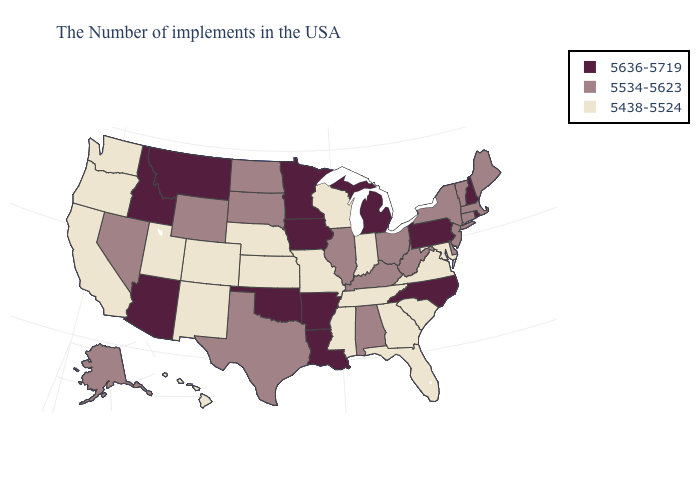What is the highest value in the West ?
Be succinct. 5636-5719. What is the value of Iowa?
Write a very short answer. 5636-5719. Name the states that have a value in the range 5636-5719?
Quick response, please. Rhode Island, New Hampshire, Pennsylvania, North Carolina, Michigan, Louisiana, Arkansas, Minnesota, Iowa, Oklahoma, Montana, Arizona, Idaho. Does Iowa have the highest value in the USA?
Write a very short answer. Yes. Does Colorado have the highest value in the West?
Keep it brief. No. Name the states that have a value in the range 5534-5623?
Be succinct. Maine, Massachusetts, Vermont, Connecticut, New York, New Jersey, Delaware, West Virginia, Ohio, Kentucky, Alabama, Illinois, Texas, South Dakota, North Dakota, Wyoming, Nevada, Alaska. How many symbols are there in the legend?
Quick response, please. 3. Which states hav the highest value in the South?
Write a very short answer. North Carolina, Louisiana, Arkansas, Oklahoma. Name the states that have a value in the range 5438-5524?
Quick response, please. Maryland, Virginia, South Carolina, Florida, Georgia, Indiana, Tennessee, Wisconsin, Mississippi, Missouri, Kansas, Nebraska, Colorado, New Mexico, Utah, California, Washington, Oregon, Hawaii. Name the states that have a value in the range 5636-5719?
Keep it brief. Rhode Island, New Hampshire, Pennsylvania, North Carolina, Michigan, Louisiana, Arkansas, Minnesota, Iowa, Oklahoma, Montana, Arizona, Idaho. Name the states that have a value in the range 5534-5623?
Write a very short answer. Maine, Massachusetts, Vermont, Connecticut, New York, New Jersey, Delaware, West Virginia, Ohio, Kentucky, Alabama, Illinois, Texas, South Dakota, North Dakota, Wyoming, Nevada, Alaska. How many symbols are there in the legend?
Keep it brief. 3. What is the value of Arkansas?
Concise answer only. 5636-5719. Does North Dakota have the highest value in the USA?
Short answer required. No. Does the map have missing data?
Give a very brief answer. No. 